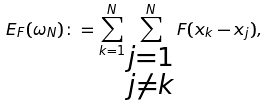Convert formula to latex. <formula><loc_0><loc_0><loc_500><loc_500>E _ { F } ( \omega _ { N } ) \colon = \sum _ { k = 1 } ^ { N } \sum _ { \substack { j = 1 \\ j \neq k } } ^ { N } F ( x _ { k } - x _ { j } ) ,</formula> 